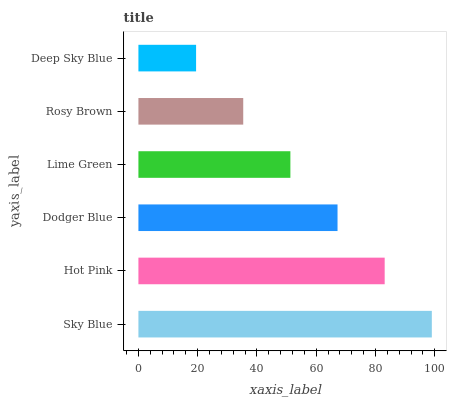Is Deep Sky Blue the minimum?
Answer yes or no. Yes. Is Sky Blue the maximum?
Answer yes or no. Yes. Is Hot Pink the minimum?
Answer yes or no. No. Is Hot Pink the maximum?
Answer yes or no. No. Is Sky Blue greater than Hot Pink?
Answer yes or no. Yes. Is Hot Pink less than Sky Blue?
Answer yes or no. Yes. Is Hot Pink greater than Sky Blue?
Answer yes or no. No. Is Sky Blue less than Hot Pink?
Answer yes or no. No. Is Dodger Blue the high median?
Answer yes or no. Yes. Is Lime Green the low median?
Answer yes or no. Yes. Is Lime Green the high median?
Answer yes or no. No. Is Deep Sky Blue the low median?
Answer yes or no. No. 